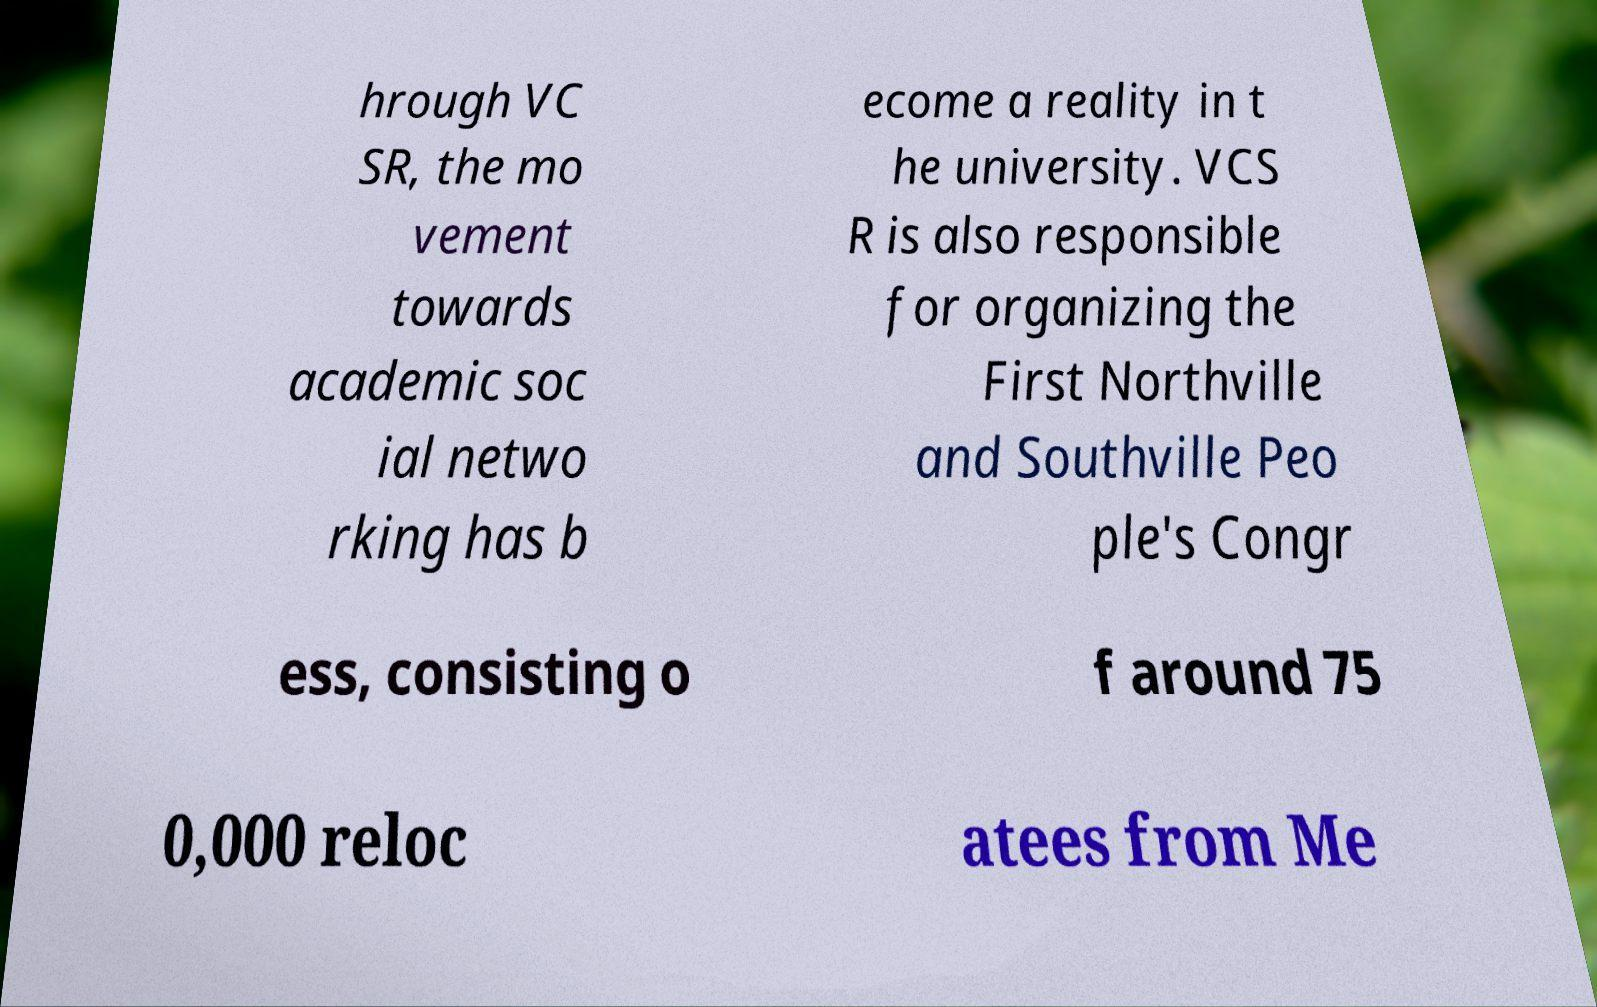Please read and relay the text visible in this image. What does it say? hrough VC SR, the mo vement towards academic soc ial netwo rking has b ecome a reality in t he university. VCS R is also responsible for organizing the First Northville and Southville Peo ple's Congr ess, consisting o f around 75 0,000 reloc atees from Me 